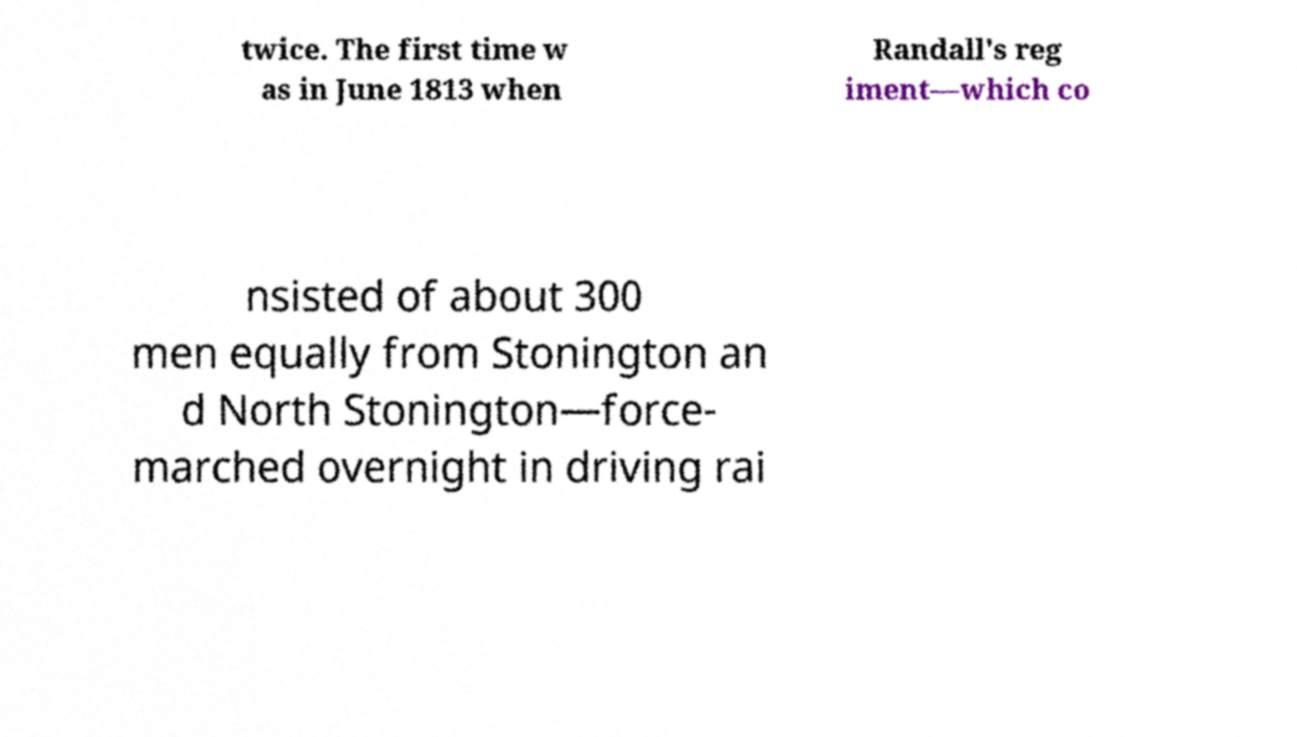There's text embedded in this image that I need extracted. Can you transcribe it verbatim? twice. The first time w as in June 1813 when Randall's reg iment—which co nsisted of about 300 men equally from Stonington an d North Stonington—force- marched overnight in driving rai 